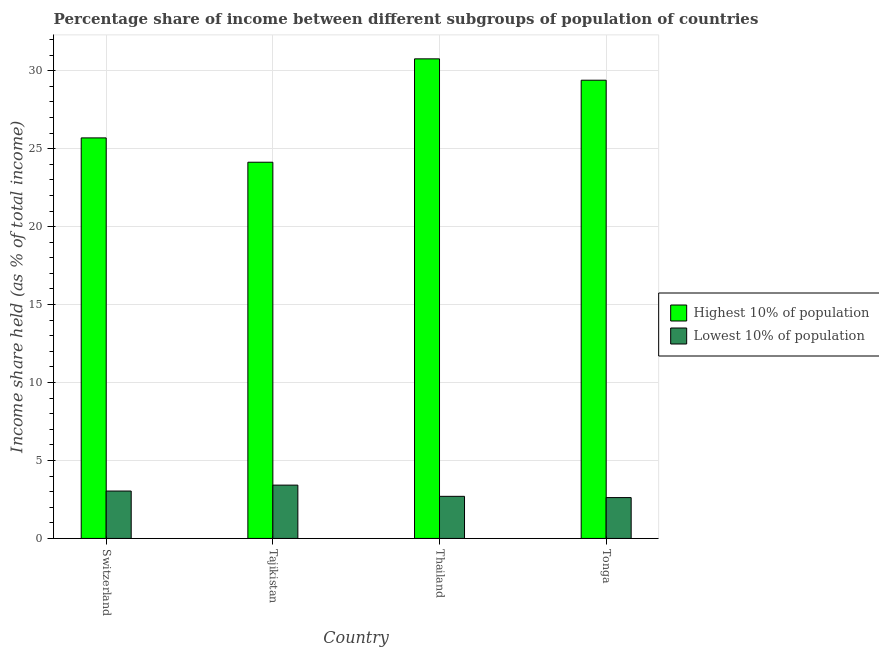Are the number of bars on each tick of the X-axis equal?
Make the answer very short. Yes. How many bars are there on the 1st tick from the left?
Give a very brief answer. 2. What is the label of the 1st group of bars from the left?
Provide a succinct answer. Switzerland. What is the income share held by lowest 10% of the population in Tonga?
Make the answer very short. 2.62. Across all countries, what is the maximum income share held by highest 10% of the population?
Keep it short and to the point. 30.76. Across all countries, what is the minimum income share held by lowest 10% of the population?
Offer a very short reply. 2.62. In which country was the income share held by highest 10% of the population maximum?
Give a very brief answer. Thailand. In which country was the income share held by highest 10% of the population minimum?
Ensure brevity in your answer.  Tajikistan. What is the total income share held by lowest 10% of the population in the graph?
Your answer should be compact. 11.78. What is the difference between the income share held by highest 10% of the population in Switzerland and that in Thailand?
Keep it short and to the point. -5.07. What is the difference between the income share held by lowest 10% of the population in Tajikistan and the income share held by highest 10% of the population in Switzerland?
Provide a succinct answer. -22.27. What is the average income share held by lowest 10% of the population per country?
Provide a succinct answer. 2.95. What is the difference between the income share held by lowest 10% of the population and income share held by highest 10% of the population in Switzerland?
Offer a very short reply. -22.65. What is the ratio of the income share held by highest 10% of the population in Tajikistan to that in Thailand?
Offer a terse response. 0.78. What is the difference between the highest and the second highest income share held by highest 10% of the population?
Make the answer very short. 1.37. What is the difference between the highest and the lowest income share held by lowest 10% of the population?
Provide a short and direct response. 0.8. What does the 2nd bar from the left in Tonga represents?
Your answer should be very brief. Lowest 10% of population. What does the 1st bar from the right in Tonga represents?
Your answer should be compact. Lowest 10% of population. How many countries are there in the graph?
Provide a succinct answer. 4. What is the difference between two consecutive major ticks on the Y-axis?
Ensure brevity in your answer.  5. Does the graph contain grids?
Keep it short and to the point. Yes. Where does the legend appear in the graph?
Keep it short and to the point. Center right. How many legend labels are there?
Provide a succinct answer. 2. What is the title of the graph?
Offer a very short reply. Percentage share of income between different subgroups of population of countries. What is the label or title of the Y-axis?
Make the answer very short. Income share held (as % of total income). What is the Income share held (as % of total income) in Highest 10% of population in Switzerland?
Ensure brevity in your answer.  25.69. What is the Income share held (as % of total income) in Lowest 10% of population in Switzerland?
Provide a succinct answer. 3.04. What is the Income share held (as % of total income) of Highest 10% of population in Tajikistan?
Your answer should be compact. 24.13. What is the Income share held (as % of total income) in Lowest 10% of population in Tajikistan?
Your response must be concise. 3.42. What is the Income share held (as % of total income) in Highest 10% of population in Thailand?
Make the answer very short. 30.76. What is the Income share held (as % of total income) in Lowest 10% of population in Thailand?
Give a very brief answer. 2.7. What is the Income share held (as % of total income) in Highest 10% of population in Tonga?
Provide a short and direct response. 29.39. What is the Income share held (as % of total income) in Lowest 10% of population in Tonga?
Your response must be concise. 2.62. Across all countries, what is the maximum Income share held (as % of total income) in Highest 10% of population?
Provide a short and direct response. 30.76. Across all countries, what is the maximum Income share held (as % of total income) in Lowest 10% of population?
Ensure brevity in your answer.  3.42. Across all countries, what is the minimum Income share held (as % of total income) in Highest 10% of population?
Provide a succinct answer. 24.13. Across all countries, what is the minimum Income share held (as % of total income) in Lowest 10% of population?
Ensure brevity in your answer.  2.62. What is the total Income share held (as % of total income) in Highest 10% of population in the graph?
Provide a short and direct response. 109.97. What is the total Income share held (as % of total income) of Lowest 10% of population in the graph?
Give a very brief answer. 11.78. What is the difference between the Income share held (as % of total income) in Highest 10% of population in Switzerland and that in Tajikistan?
Your answer should be compact. 1.56. What is the difference between the Income share held (as % of total income) in Lowest 10% of population in Switzerland and that in Tajikistan?
Your response must be concise. -0.38. What is the difference between the Income share held (as % of total income) of Highest 10% of population in Switzerland and that in Thailand?
Keep it short and to the point. -5.07. What is the difference between the Income share held (as % of total income) of Lowest 10% of population in Switzerland and that in Thailand?
Provide a succinct answer. 0.34. What is the difference between the Income share held (as % of total income) of Lowest 10% of population in Switzerland and that in Tonga?
Make the answer very short. 0.42. What is the difference between the Income share held (as % of total income) in Highest 10% of population in Tajikistan and that in Thailand?
Make the answer very short. -6.63. What is the difference between the Income share held (as % of total income) in Lowest 10% of population in Tajikistan and that in Thailand?
Your answer should be very brief. 0.72. What is the difference between the Income share held (as % of total income) in Highest 10% of population in Tajikistan and that in Tonga?
Offer a terse response. -5.26. What is the difference between the Income share held (as % of total income) of Highest 10% of population in Thailand and that in Tonga?
Your answer should be compact. 1.37. What is the difference between the Income share held (as % of total income) in Highest 10% of population in Switzerland and the Income share held (as % of total income) in Lowest 10% of population in Tajikistan?
Provide a short and direct response. 22.27. What is the difference between the Income share held (as % of total income) in Highest 10% of population in Switzerland and the Income share held (as % of total income) in Lowest 10% of population in Thailand?
Keep it short and to the point. 22.99. What is the difference between the Income share held (as % of total income) in Highest 10% of population in Switzerland and the Income share held (as % of total income) in Lowest 10% of population in Tonga?
Offer a terse response. 23.07. What is the difference between the Income share held (as % of total income) in Highest 10% of population in Tajikistan and the Income share held (as % of total income) in Lowest 10% of population in Thailand?
Ensure brevity in your answer.  21.43. What is the difference between the Income share held (as % of total income) in Highest 10% of population in Tajikistan and the Income share held (as % of total income) in Lowest 10% of population in Tonga?
Your response must be concise. 21.51. What is the difference between the Income share held (as % of total income) of Highest 10% of population in Thailand and the Income share held (as % of total income) of Lowest 10% of population in Tonga?
Offer a very short reply. 28.14. What is the average Income share held (as % of total income) in Highest 10% of population per country?
Your answer should be very brief. 27.49. What is the average Income share held (as % of total income) in Lowest 10% of population per country?
Provide a short and direct response. 2.94. What is the difference between the Income share held (as % of total income) of Highest 10% of population and Income share held (as % of total income) of Lowest 10% of population in Switzerland?
Ensure brevity in your answer.  22.65. What is the difference between the Income share held (as % of total income) in Highest 10% of population and Income share held (as % of total income) in Lowest 10% of population in Tajikistan?
Your answer should be very brief. 20.71. What is the difference between the Income share held (as % of total income) of Highest 10% of population and Income share held (as % of total income) of Lowest 10% of population in Thailand?
Your response must be concise. 28.06. What is the difference between the Income share held (as % of total income) of Highest 10% of population and Income share held (as % of total income) of Lowest 10% of population in Tonga?
Provide a short and direct response. 26.77. What is the ratio of the Income share held (as % of total income) in Highest 10% of population in Switzerland to that in Tajikistan?
Provide a short and direct response. 1.06. What is the ratio of the Income share held (as % of total income) in Lowest 10% of population in Switzerland to that in Tajikistan?
Offer a terse response. 0.89. What is the ratio of the Income share held (as % of total income) of Highest 10% of population in Switzerland to that in Thailand?
Offer a very short reply. 0.84. What is the ratio of the Income share held (as % of total income) in Lowest 10% of population in Switzerland to that in Thailand?
Offer a terse response. 1.13. What is the ratio of the Income share held (as % of total income) of Highest 10% of population in Switzerland to that in Tonga?
Provide a succinct answer. 0.87. What is the ratio of the Income share held (as % of total income) of Lowest 10% of population in Switzerland to that in Tonga?
Make the answer very short. 1.16. What is the ratio of the Income share held (as % of total income) of Highest 10% of population in Tajikistan to that in Thailand?
Your answer should be very brief. 0.78. What is the ratio of the Income share held (as % of total income) in Lowest 10% of population in Tajikistan to that in Thailand?
Ensure brevity in your answer.  1.27. What is the ratio of the Income share held (as % of total income) in Highest 10% of population in Tajikistan to that in Tonga?
Provide a short and direct response. 0.82. What is the ratio of the Income share held (as % of total income) in Lowest 10% of population in Tajikistan to that in Tonga?
Provide a succinct answer. 1.31. What is the ratio of the Income share held (as % of total income) in Highest 10% of population in Thailand to that in Tonga?
Offer a terse response. 1.05. What is the ratio of the Income share held (as % of total income) of Lowest 10% of population in Thailand to that in Tonga?
Provide a succinct answer. 1.03. What is the difference between the highest and the second highest Income share held (as % of total income) in Highest 10% of population?
Provide a short and direct response. 1.37. What is the difference between the highest and the second highest Income share held (as % of total income) of Lowest 10% of population?
Make the answer very short. 0.38. What is the difference between the highest and the lowest Income share held (as % of total income) in Highest 10% of population?
Give a very brief answer. 6.63. What is the difference between the highest and the lowest Income share held (as % of total income) of Lowest 10% of population?
Make the answer very short. 0.8. 